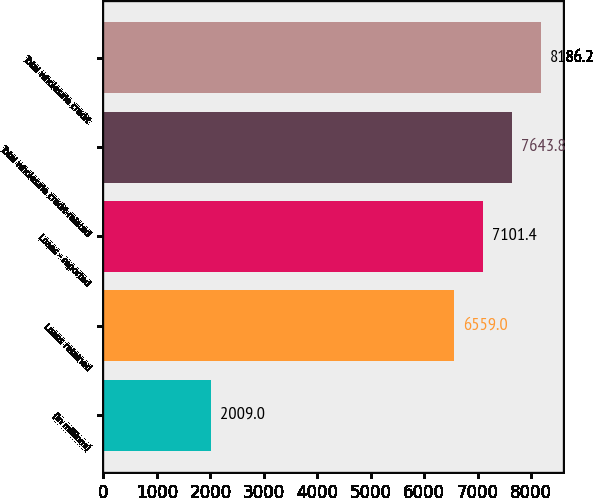<chart> <loc_0><loc_0><loc_500><loc_500><bar_chart><fcel>(in millions)<fcel>Loans retained<fcel>Loans - reported<fcel>Total wholesale credit-related<fcel>Total wholesale credit<nl><fcel>2009<fcel>6559<fcel>7101.4<fcel>7643.8<fcel>8186.2<nl></chart> 